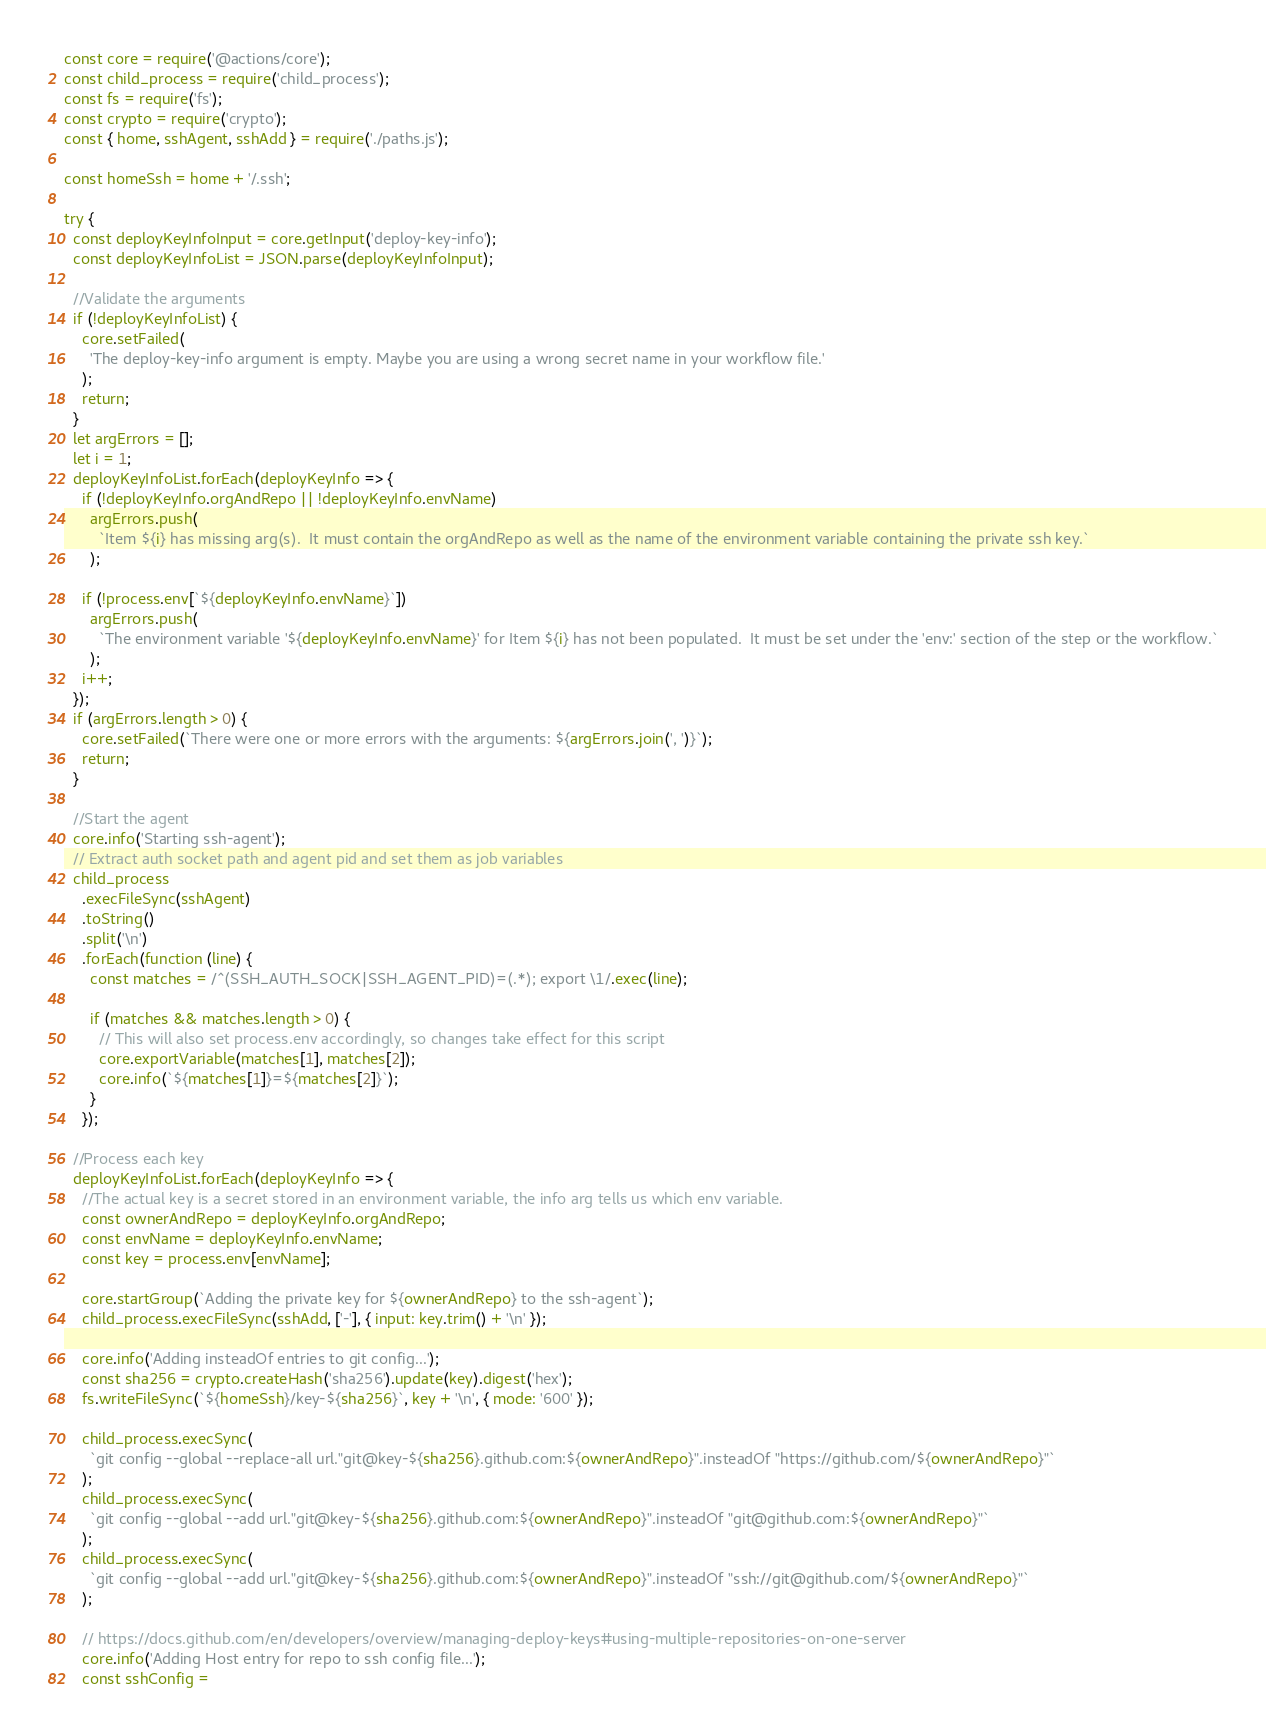<code> <loc_0><loc_0><loc_500><loc_500><_JavaScript_>const core = require('@actions/core');
const child_process = require('child_process');
const fs = require('fs');
const crypto = require('crypto');
const { home, sshAgent, sshAdd } = require('./paths.js');

const homeSsh = home + '/.ssh';

try {
  const deployKeyInfoInput = core.getInput('deploy-key-info');
  const deployKeyInfoList = JSON.parse(deployKeyInfoInput);

  //Validate the arguments
  if (!deployKeyInfoList) {
    core.setFailed(
      'The deploy-key-info argument is empty. Maybe you are using a wrong secret name in your workflow file.'
    );
    return;
  }
  let argErrors = [];
  let i = 1;
  deployKeyInfoList.forEach(deployKeyInfo => {
    if (!deployKeyInfo.orgAndRepo || !deployKeyInfo.envName)
      argErrors.push(
        `Item ${i} has missing arg(s).  It must contain the orgAndRepo as well as the name of the environment variable containing the private ssh key.`
      );

    if (!process.env[`${deployKeyInfo.envName}`])
      argErrors.push(
        `The environment variable '${deployKeyInfo.envName}' for Item ${i} has not been populated.  It must be set under the 'env:' section of the step or the workflow.`
      );
    i++;
  });
  if (argErrors.length > 0) {
    core.setFailed(`There were one or more errors with the arguments: ${argErrors.join(', ')}`);
    return;
  }

  //Start the agent
  core.info('Starting ssh-agent');
  // Extract auth socket path and agent pid and set them as job variables
  child_process
    .execFileSync(sshAgent)
    .toString()
    .split('\n')
    .forEach(function (line) {
      const matches = /^(SSH_AUTH_SOCK|SSH_AGENT_PID)=(.*); export \1/.exec(line);

      if (matches && matches.length > 0) {
        // This will also set process.env accordingly, so changes take effect for this script
        core.exportVariable(matches[1], matches[2]);
        core.info(`${matches[1]}=${matches[2]}`);
      }
    });

  //Process each key
  deployKeyInfoList.forEach(deployKeyInfo => {
    //The actual key is a secret stored in an environment variable, the info arg tells us which env variable.
    const ownerAndRepo = deployKeyInfo.orgAndRepo;
    const envName = deployKeyInfo.envName;
    const key = process.env[envName];

    core.startGroup(`Adding the private key for ${ownerAndRepo} to the ssh-agent`);
    child_process.execFileSync(sshAdd, ['-'], { input: key.trim() + '\n' });

    core.info('Adding insteadOf entries to git config...');
    const sha256 = crypto.createHash('sha256').update(key).digest('hex');
    fs.writeFileSync(`${homeSsh}/key-${sha256}`, key + '\n', { mode: '600' });

    child_process.execSync(
      `git config --global --replace-all url."git@key-${sha256}.github.com:${ownerAndRepo}".insteadOf "https://github.com/${ownerAndRepo}"`
    );
    child_process.execSync(
      `git config --global --add url."git@key-${sha256}.github.com:${ownerAndRepo}".insteadOf "git@github.com:${ownerAndRepo}"`
    );
    child_process.execSync(
      `git config --global --add url."git@key-${sha256}.github.com:${ownerAndRepo}".insteadOf "ssh://git@github.com/${ownerAndRepo}"`
    );

    // https://docs.github.com/en/developers/overview/managing-deploy-keys#using-multiple-repositories-on-one-server
    core.info('Adding Host entry for repo to ssh config file...');
    const sshConfig =</code> 